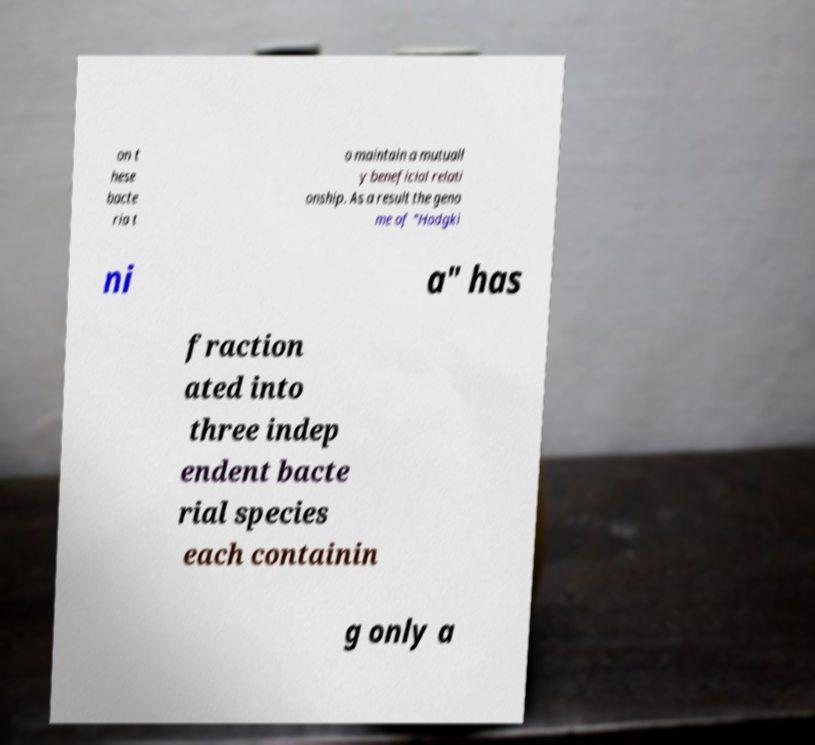Could you assist in decoding the text presented in this image and type it out clearly? on t hese bacte ria t o maintain a mutuall y beneficial relati onship. As a result the geno me of "Hodgki ni a" has fraction ated into three indep endent bacte rial species each containin g only a 